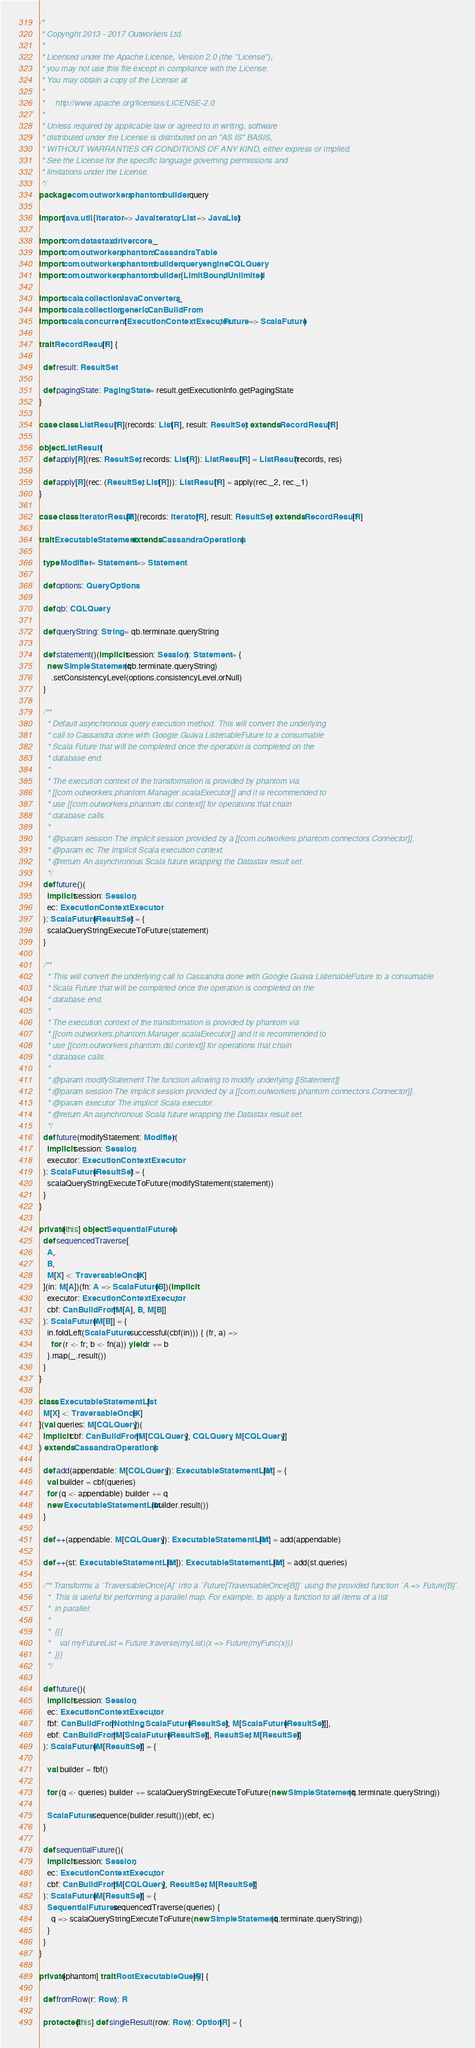<code> <loc_0><loc_0><loc_500><loc_500><_Scala_>/*
 * Copyright 2013 - 2017 Outworkers Ltd.
 *
 * Licensed under the Apache License, Version 2.0 (the "License");
 * you may not use this file except in compliance with the License.
 * You may obtain a copy of the License at
 *
 *     http://www.apache.org/licenses/LICENSE-2.0
 *
 * Unless required by applicable law or agreed to in writing, software
 * distributed under the License is distributed on an "AS IS" BASIS,
 * WITHOUT WARRANTIES OR CONDITIONS OF ANY KIND, either express or implied.
 * See the License for the specific language governing permissions and
 * limitations under the License.
 */
package com.outworkers.phantom.builder.query

import java.util.{Iterator => JavaIterator, List => JavaList}

import com.datastax.driver.core._
import com.outworkers.phantom.CassandraTable
import com.outworkers.phantom.builder.query.engine.CQLQuery
import com.outworkers.phantom.builder.{LimitBound, Unlimited}

import scala.collection.JavaConverters._
import scala.collection.generic.CanBuildFrom
import scala.concurrent.{ExecutionContextExecutor, Future => ScalaFuture}

trait RecordResult[R] {

  def result: ResultSet

  def pagingState: PagingState = result.getExecutionInfo.getPagingState
}

case class ListResult[R](records: List[R], result: ResultSet) extends RecordResult[R]

object ListResult {
  def apply[R](res: ResultSet, records: List[R]): ListResult[R] = ListResult(records, res)

  def apply[R](rec: (ResultSet, List[R])): ListResult[R] = apply(rec._2, rec._1)
}

case class IteratorResult[R](records: Iterator[R], result: ResultSet) extends RecordResult[R]

trait ExecutableStatement extends CassandraOperations {

  type Modifier = Statement => Statement

  def options: QueryOptions

  def qb: CQLQuery

  def queryString: String = qb.terminate.queryString

  def statement()(implicit session: Session): Statement = {
    new SimpleStatement(qb.terminate.queryString)
      .setConsistencyLevel(options.consistencyLevel.orNull)
  }

  /**
    * Default asynchronous query execution method. This will convert the underlying
    * call to Cassandra done with Google Guava ListenableFuture to a consumable
    * Scala Future that will be completed once the operation is completed on the
    * database end.
    *
    * The execution context of the transformation is provided by phantom via
    * [[com.outworkers.phantom.Manager.scalaExecutor]] and it is recommended to
    * use [[com.outworkers.phantom.dsl.context]] for operations that chain
    * database calls.
    *
    * @param session The implicit session provided by a [[com.outworkers.phantom.connectors.Connector]].
    * @param ec The implicit Scala execution context.
    * @return An asynchronous Scala future wrapping the Datastax result set.
    */
  def future()(
    implicit session: Session,
    ec: ExecutionContextExecutor
  ): ScalaFuture[ResultSet] = {
    scalaQueryStringExecuteToFuture(statement)
  }

  /**
    * This will convert the underlying call to Cassandra done with Google Guava ListenableFuture to a consumable
    * Scala Future that will be completed once the operation is completed on the
    * database end.
    *
    * The execution context of the transformation is provided by phantom via
    * [[com.outworkers.phantom.Manager.scalaExecutor]] and it is recommended to
    * use [[com.outworkers.phantom.dsl.context]] for operations that chain
    * database calls.
    *
    * @param modifyStatement The function allowing to modify underlying [[Statement]]
    * @param session The implicit session provided by a [[com.outworkers.phantom.connectors.Connector]].
    * @param executor The implicit Scala executor.
    * @return An asynchronous Scala future wrapping the Datastax result set.
    */
  def future(modifyStatement: Modifier)(
    implicit session: Session,
    executor: ExecutionContextExecutor
  ): ScalaFuture[ResultSet] = {
    scalaQueryStringExecuteToFuture(modifyStatement(statement))
  }
}

private[this] object SequentialFutures {
  def sequencedTraverse[
    A,
    B,
    M[X] <: TraversableOnce[X]
  ](in: M[A])(fn: A => ScalaFuture[B])(implicit
    executor: ExecutionContextExecutor,
    cbf: CanBuildFrom[M[A], B, M[B]]
  ): ScalaFuture[M[B]] = {
    in.foldLeft(ScalaFuture.successful(cbf(in))) { (fr, a) =>
      for (r <- fr; b <- fn(a)) yield r += b
    }.map(_.result())
  }
}

class ExecutableStatementList[
  M[X] <: TraversableOnce[X]
](val queries: M[CQLQuery])(
  implicit cbf: CanBuildFrom[M[CQLQuery], CQLQuery, M[CQLQuery]]
) extends CassandraOperations {

  def add(appendable: M[CQLQuery]): ExecutableStatementList[M] = {
    val builder = cbf(queries)
    for (q <- appendable) builder += q
    new ExecutableStatementList(builder.result())
  }

  def ++(appendable: M[CQLQuery]): ExecutableStatementList[M] = add(appendable)

  def ++(st: ExecutableStatementList[M]): ExecutableStatementList[M] = add(st.queries)

  /** Transforms a `TraversableOnce[A]` into a `Future[TraversableOnce[B]]` using the provided function `A => Future[B]`.
    *  This is useful for performing a parallel map. For example, to apply a function to all items of a list
    *  in parallel:
    *
    *  {{{
    *    val myFutureList = Future.traverse(myList)(x => Future(myFunc(x)))
    *  }}}
    */

  def future()(
    implicit session: Session,
    ec: ExecutionContextExecutor,
    fbf: CanBuildFrom[Nothing, ScalaFuture[ResultSet], M[ScalaFuture[ResultSet]]],
    ebf: CanBuildFrom[M[ScalaFuture[ResultSet]], ResultSet, M[ResultSet]]
  ): ScalaFuture[M[ResultSet]] = {

    val builder = fbf()

    for (q <- queries) builder += scalaQueryStringExecuteToFuture(new SimpleStatement(q.terminate.queryString))

    ScalaFuture.sequence(builder.result())(ebf, ec)
  }

  def sequentialFuture()(
    implicit session: Session,
    ec: ExecutionContextExecutor,
    cbf: CanBuildFrom[M[CQLQuery], ResultSet, M[ResultSet]]
  ): ScalaFuture[M[ResultSet]] = {
    SequentialFutures.sequencedTraverse(queries) {
      q => scalaQueryStringExecuteToFuture(new SimpleStatement(q.terminate.queryString))
    }
  }
}

private[phantom] trait RootExecutableQuery[R] {

  def fromRow(r: Row): R

  protected[this] def singleResult(row: Row): Option[R] = {</code> 